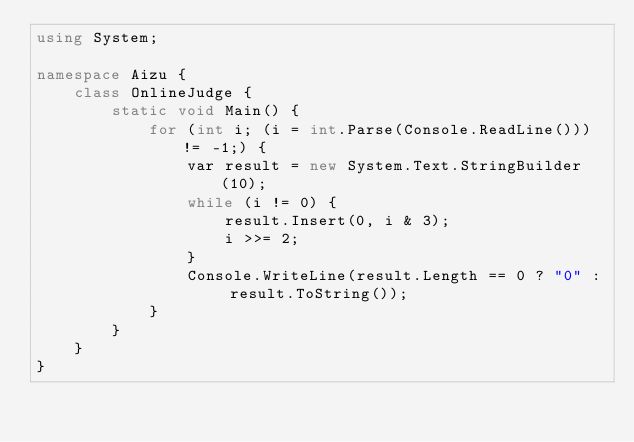<code> <loc_0><loc_0><loc_500><loc_500><_C#_>using System;

namespace Aizu {
    class OnlineJudge {
        static void Main() {
            for (int i; (i = int.Parse(Console.ReadLine())) != -1;) {
                var result = new System.Text.StringBuilder(10);
                while (i != 0) {
                    result.Insert(0, i & 3);
                    i >>= 2;
                }
                Console.WriteLine(result.Length == 0 ? "0" : result.ToString());
            }
        }
    }
}</code> 